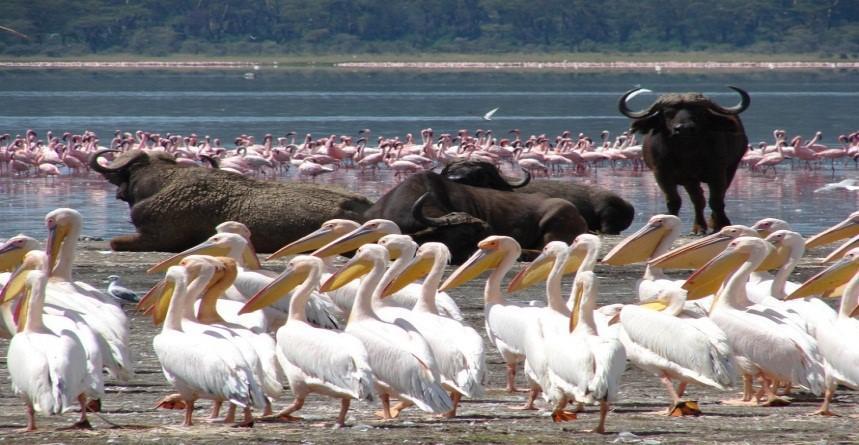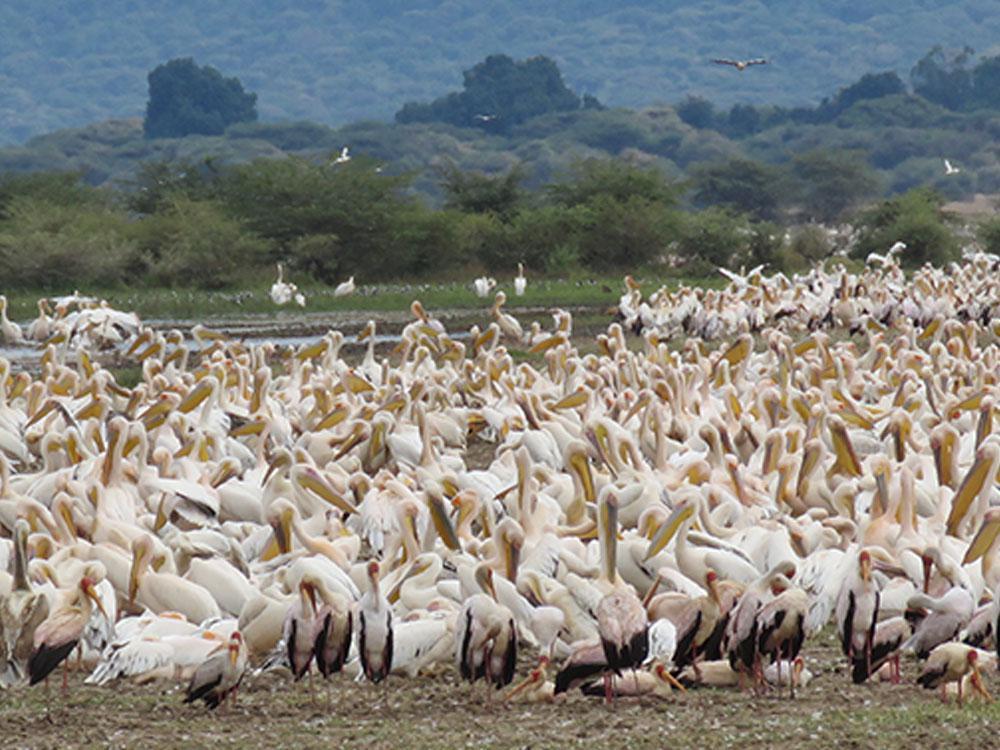The first image is the image on the left, the second image is the image on the right. Assess this claim about the two images: "In one image, nearly all pelicans in the foreground face leftward.". Correct or not? Answer yes or no. Yes. The first image is the image on the left, the second image is the image on the right. Evaluate the accuracy of this statement regarding the images: "A few of the birds are in the air in one one the images.". Is it true? Answer yes or no. Yes. 